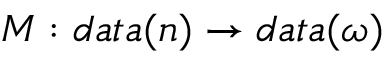Convert formula to latex. <formula><loc_0><loc_0><loc_500><loc_500>M \colon d a t a ( n ) \rightarrow d a t a ( \omega )</formula> 